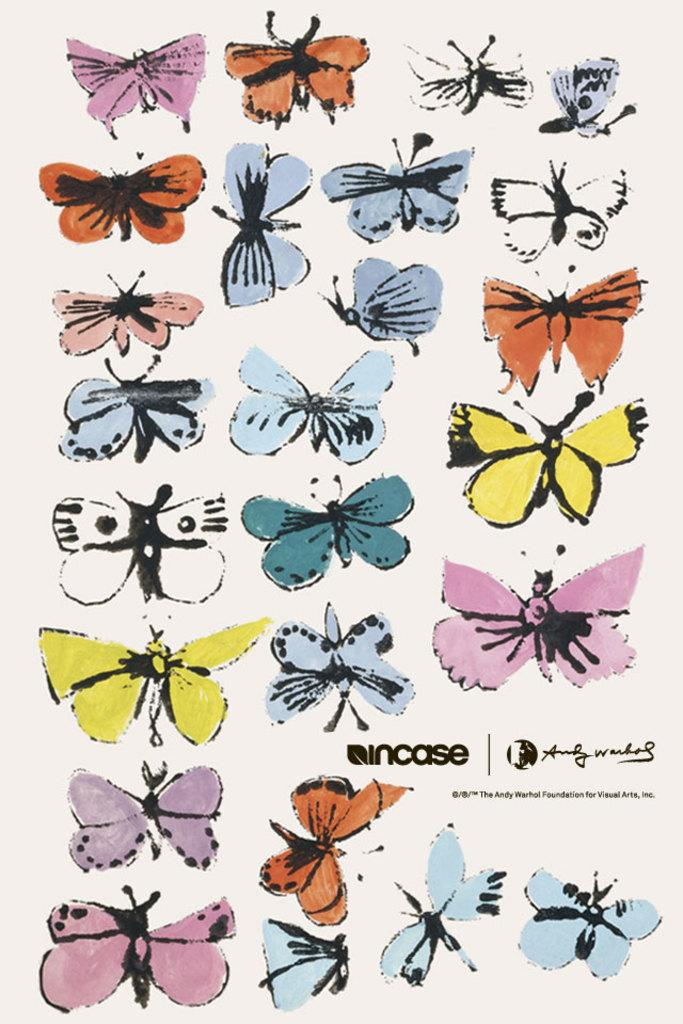What type of animals can be seen in the image? There are butterflies in the image. What colors are the butterflies? The butterflies are in multiple colors. What is the background color of the image? The background of the image is white. What type of fruit is the butterfly holding in the image? Butterflies do not hold fruit, and there is no fruit present in the image. 